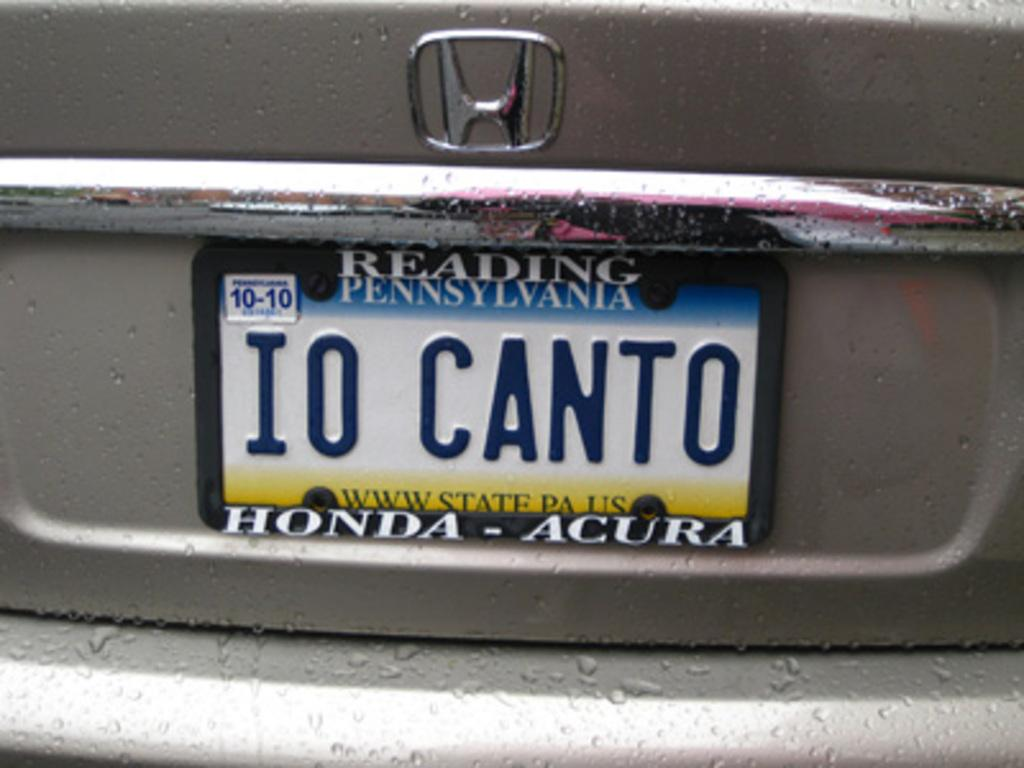<image>
Relay a brief, clear account of the picture shown. A Pennsylvania license plate reads IO CANTO and is from Honda. 